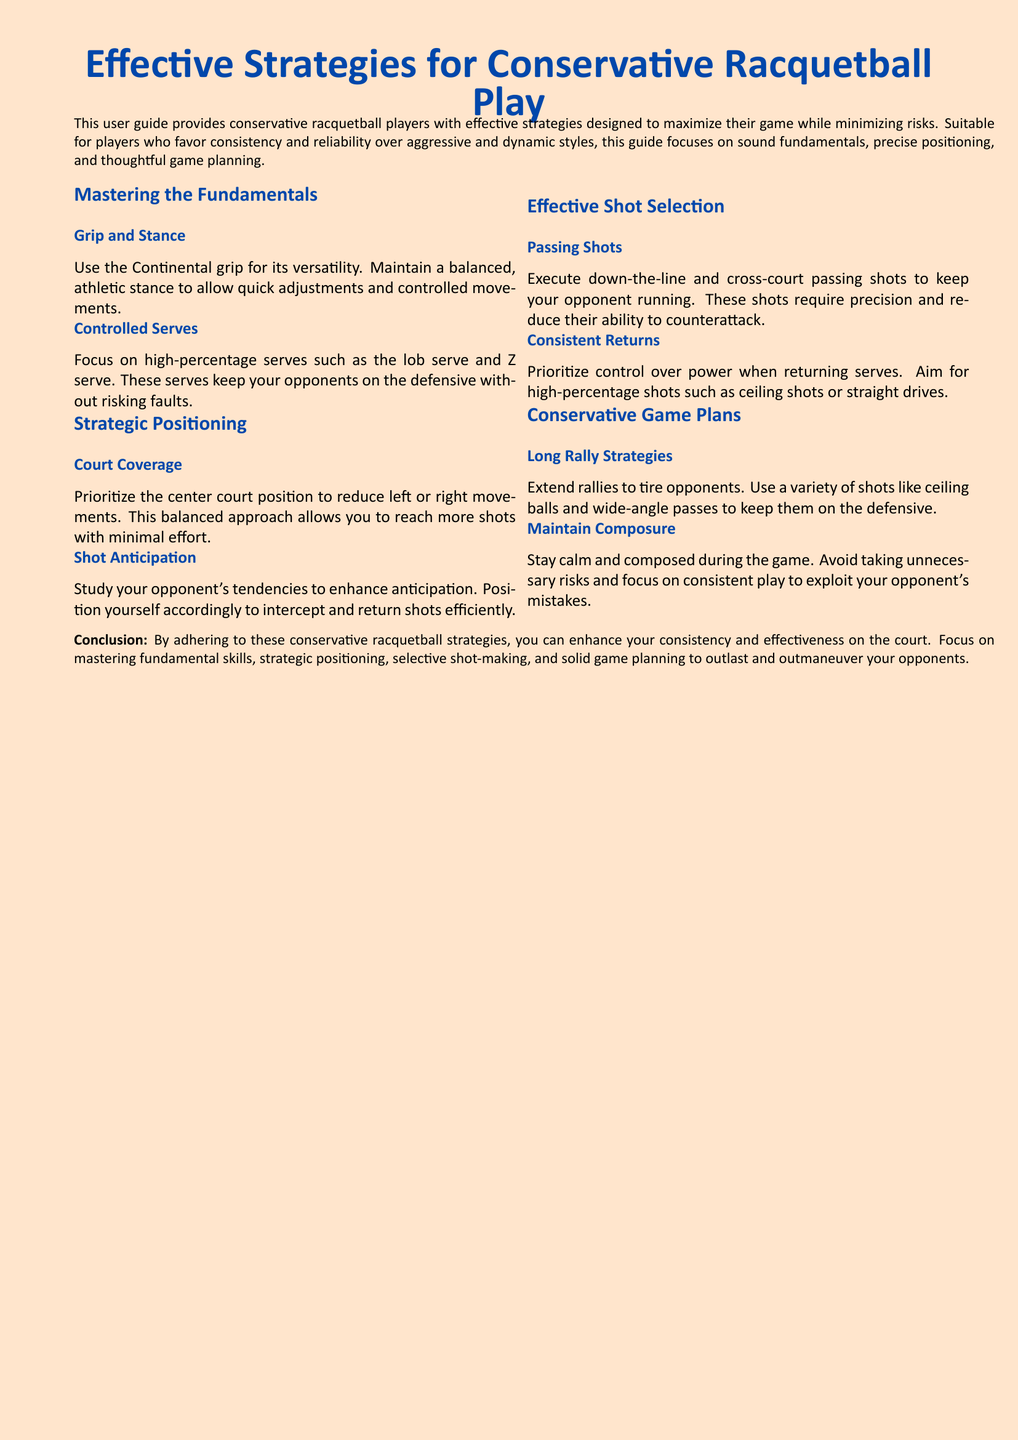What grip is recommended for conservative racquetball players? The guide suggests using the Continental grip for its versatility.
Answer: Continental grip What is emphasized for controlled serves? The document highlights focusing on high-percentage serves like the lob serve and Z serve.
Answer: High-percentage serves Which court position should conservative players prioritize? Players are advised to prioritize the center court position to reduce movement.
Answer: Center court position What type of shots should players execute to tire opponents? The strategy involves using a variety of shots such as ceiling balls and wide-angle passes.
Answer: Ceiling balls and wide-angle passes What key aspect should players maintain during the game? The guide stresses the importance of staying calm and composed during the game.
Answer: Composed What is the primary focus when returning serves according to the guide? The guide advises prioritizing control over power when returning serves.
Answer: Control over power What is the purpose of shot anticipation? Enhancing shot anticipation helps players intercept and return shots efficiently.
Answer: Intercepting and returning shots Which strategies increase rallies according to the document? Long rally strategies are recommended to extend rallies and tire opponents.
Answer: Long rally strategies 